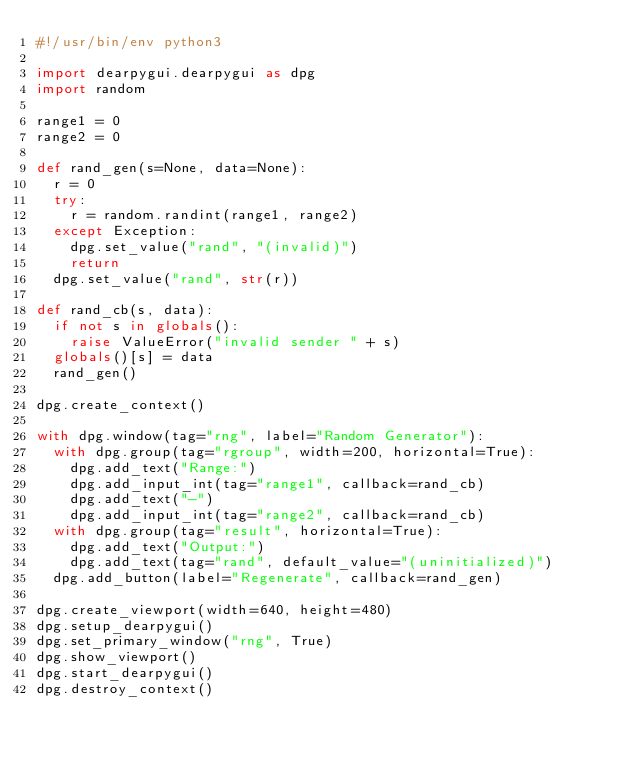<code> <loc_0><loc_0><loc_500><loc_500><_Python_>#!/usr/bin/env python3

import dearpygui.dearpygui as dpg
import random

range1 = 0
range2 = 0

def rand_gen(s=None, data=None):
	r = 0
	try:
		r = random.randint(range1, range2)
	except Exception:
		dpg.set_value("rand", "(invalid)")
		return
	dpg.set_value("rand", str(r))

def rand_cb(s, data):
	if not s in globals():
		raise ValueError("invalid sender " + s)
	globals()[s] = data
	rand_gen()

dpg.create_context()

with dpg.window(tag="rng", label="Random Generator"):
	with dpg.group(tag="rgroup", width=200, horizontal=True):
		dpg.add_text("Range:")
		dpg.add_input_int(tag="range1", callback=rand_cb)
		dpg.add_text("-")
		dpg.add_input_int(tag="range2", callback=rand_cb)
	with dpg.group(tag="result", horizontal=True):
		dpg.add_text("Output:")
		dpg.add_text(tag="rand", default_value="(uninitialized)")
	dpg.add_button(label="Regenerate", callback=rand_gen)

dpg.create_viewport(width=640, height=480)
dpg.setup_dearpygui()
dpg.set_primary_window("rng", True)
dpg.show_viewport()
dpg.start_dearpygui()
dpg.destroy_context()
</code> 